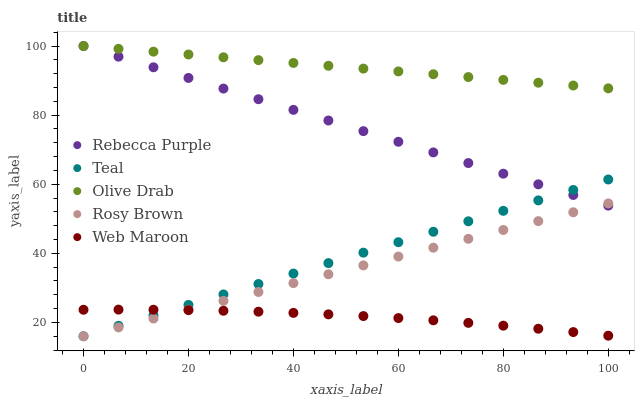Does Web Maroon have the minimum area under the curve?
Answer yes or no. Yes. Does Olive Drab have the maximum area under the curve?
Answer yes or no. Yes. Does Rosy Brown have the minimum area under the curve?
Answer yes or no. No. Does Rosy Brown have the maximum area under the curve?
Answer yes or no. No. Is Teal the smoothest?
Answer yes or no. Yes. Is Web Maroon the roughest?
Answer yes or no. Yes. Is Rosy Brown the smoothest?
Answer yes or no. No. Is Rosy Brown the roughest?
Answer yes or no. No. Does Rosy Brown have the lowest value?
Answer yes or no. Yes. Does Web Maroon have the lowest value?
Answer yes or no. No. Does Rebecca Purple have the highest value?
Answer yes or no. Yes. Does Rosy Brown have the highest value?
Answer yes or no. No. Is Rosy Brown less than Olive Drab?
Answer yes or no. Yes. Is Olive Drab greater than Web Maroon?
Answer yes or no. Yes. Does Rebecca Purple intersect Teal?
Answer yes or no. Yes. Is Rebecca Purple less than Teal?
Answer yes or no. No. Is Rebecca Purple greater than Teal?
Answer yes or no. No. Does Rosy Brown intersect Olive Drab?
Answer yes or no. No. 